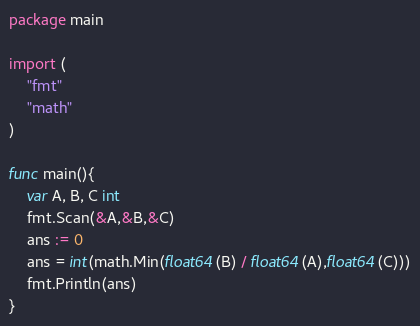<code> <loc_0><loc_0><loc_500><loc_500><_Go_>package main

import (
	"fmt"
	"math"
)

func main(){
	var A, B, C int
	fmt.Scan(&A,&B,&C)
	ans := 0
	ans = int(math.Min(float64(B) / float64(A),float64(C)))
	fmt.Println(ans)
}

</code> 